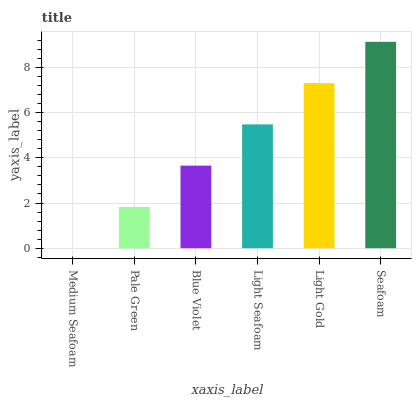Is Medium Seafoam the minimum?
Answer yes or no. Yes. Is Seafoam the maximum?
Answer yes or no. Yes. Is Pale Green the minimum?
Answer yes or no. No. Is Pale Green the maximum?
Answer yes or no. No. Is Pale Green greater than Medium Seafoam?
Answer yes or no. Yes. Is Medium Seafoam less than Pale Green?
Answer yes or no. Yes. Is Medium Seafoam greater than Pale Green?
Answer yes or no. No. Is Pale Green less than Medium Seafoam?
Answer yes or no. No. Is Light Seafoam the high median?
Answer yes or no. Yes. Is Blue Violet the low median?
Answer yes or no. Yes. Is Seafoam the high median?
Answer yes or no. No. Is Medium Seafoam the low median?
Answer yes or no. No. 